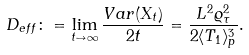<formula> <loc_0><loc_0><loc_500><loc_500>D _ { e f f } \colon = \lim _ { t \to \infty } \frac { V a r ( X _ { t } ) } { 2 t } = \frac { L ^ { 2 } \varrho _ { \tau } ^ { 2 } } { 2 \langle T _ { 1 } \rangle _ { p } ^ { 3 } } .</formula> 